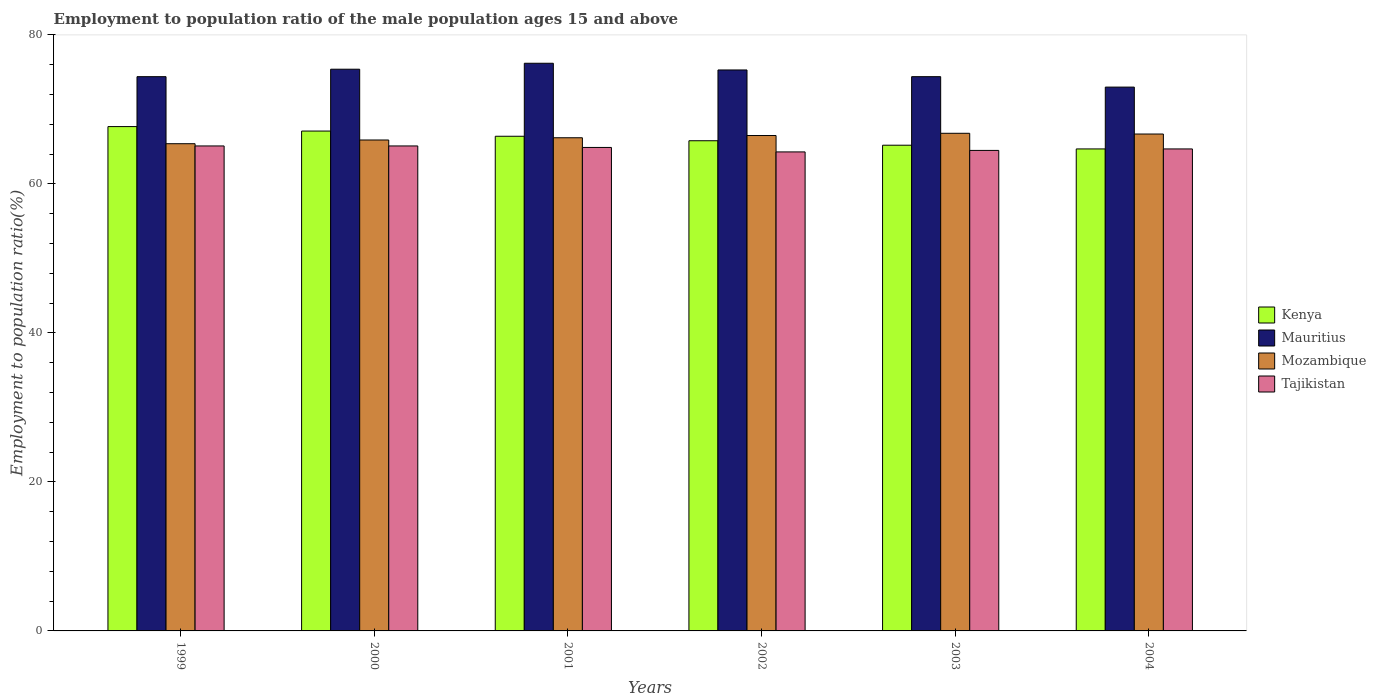How many different coloured bars are there?
Ensure brevity in your answer.  4. How many bars are there on the 5th tick from the left?
Keep it short and to the point. 4. What is the label of the 5th group of bars from the left?
Give a very brief answer. 2003. What is the employment to population ratio in Mozambique in 2002?
Give a very brief answer. 66.5. Across all years, what is the maximum employment to population ratio in Mauritius?
Your answer should be compact. 76.2. Across all years, what is the minimum employment to population ratio in Tajikistan?
Your answer should be very brief. 64.3. In which year was the employment to population ratio in Kenya maximum?
Provide a succinct answer. 1999. What is the total employment to population ratio in Kenya in the graph?
Your answer should be very brief. 396.9. What is the difference between the employment to population ratio in Mozambique in 2000 and that in 2001?
Provide a short and direct response. -0.3. What is the difference between the employment to population ratio in Mauritius in 2000 and the employment to population ratio in Kenya in 2004?
Your answer should be very brief. 10.7. What is the average employment to population ratio in Mozambique per year?
Make the answer very short. 66.25. In the year 1999, what is the difference between the employment to population ratio in Mozambique and employment to population ratio in Tajikistan?
Ensure brevity in your answer.  0.3. What is the ratio of the employment to population ratio in Mozambique in 2000 to that in 2003?
Offer a very short reply. 0.99. Is the employment to population ratio in Kenya in 1999 less than that in 2001?
Make the answer very short. No. Is the difference between the employment to population ratio in Mozambique in 2001 and 2004 greater than the difference between the employment to population ratio in Tajikistan in 2001 and 2004?
Provide a succinct answer. No. What is the difference between the highest and the second highest employment to population ratio in Kenya?
Offer a very short reply. 0.6. What is the difference between the highest and the lowest employment to population ratio in Mauritius?
Offer a terse response. 3.2. What does the 4th bar from the left in 2003 represents?
Your response must be concise. Tajikistan. What does the 4th bar from the right in 1999 represents?
Ensure brevity in your answer.  Kenya. Are all the bars in the graph horizontal?
Make the answer very short. No. How many years are there in the graph?
Your answer should be very brief. 6. What is the difference between two consecutive major ticks on the Y-axis?
Provide a succinct answer. 20. Are the values on the major ticks of Y-axis written in scientific E-notation?
Offer a very short reply. No. Does the graph contain grids?
Offer a very short reply. No. Where does the legend appear in the graph?
Your answer should be very brief. Center right. How many legend labels are there?
Provide a short and direct response. 4. How are the legend labels stacked?
Offer a terse response. Vertical. What is the title of the graph?
Give a very brief answer. Employment to population ratio of the male population ages 15 and above. What is the label or title of the X-axis?
Give a very brief answer. Years. What is the Employment to population ratio(%) in Kenya in 1999?
Give a very brief answer. 67.7. What is the Employment to population ratio(%) in Mauritius in 1999?
Provide a short and direct response. 74.4. What is the Employment to population ratio(%) of Mozambique in 1999?
Provide a short and direct response. 65.4. What is the Employment to population ratio(%) in Tajikistan in 1999?
Provide a short and direct response. 65.1. What is the Employment to population ratio(%) in Kenya in 2000?
Offer a very short reply. 67.1. What is the Employment to population ratio(%) in Mauritius in 2000?
Ensure brevity in your answer.  75.4. What is the Employment to population ratio(%) in Mozambique in 2000?
Provide a short and direct response. 65.9. What is the Employment to population ratio(%) of Tajikistan in 2000?
Provide a succinct answer. 65.1. What is the Employment to population ratio(%) of Kenya in 2001?
Keep it short and to the point. 66.4. What is the Employment to population ratio(%) in Mauritius in 2001?
Make the answer very short. 76.2. What is the Employment to population ratio(%) in Mozambique in 2001?
Provide a short and direct response. 66.2. What is the Employment to population ratio(%) in Tajikistan in 2001?
Make the answer very short. 64.9. What is the Employment to population ratio(%) in Kenya in 2002?
Make the answer very short. 65.8. What is the Employment to population ratio(%) of Mauritius in 2002?
Provide a short and direct response. 75.3. What is the Employment to population ratio(%) in Mozambique in 2002?
Offer a very short reply. 66.5. What is the Employment to population ratio(%) in Tajikistan in 2002?
Keep it short and to the point. 64.3. What is the Employment to population ratio(%) of Kenya in 2003?
Your answer should be compact. 65.2. What is the Employment to population ratio(%) in Mauritius in 2003?
Provide a succinct answer. 74.4. What is the Employment to population ratio(%) of Mozambique in 2003?
Provide a short and direct response. 66.8. What is the Employment to population ratio(%) of Tajikistan in 2003?
Ensure brevity in your answer.  64.5. What is the Employment to population ratio(%) of Kenya in 2004?
Your answer should be very brief. 64.7. What is the Employment to population ratio(%) in Mozambique in 2004?
Give a very brief answer. 66.7. What is the Employment to population ratio(%) of Tajikistan in 2004?
Ensure brevity in your answer.  64.7. Across all years, what is the maximum Employment to population ratio(%) of Kenya?
Provide a short and direct response. 67.7. Across all years, what is the maximum Employment to population ratio(%) of Mauritius?
Provide a succinct answer. 76.2. Across all years, what is the maximum Employment to population ratio(%) in Mozambique?
Give a very brief answer. 66.8. Across all years, what is the maximum Employment to population ratio(%) in Tajikistan?
Make the answer very short. 65.1. Across all years, what is the minimum Employment to population ratio(%) of Kenya?
Your response must be concise. 64.7. Across all years, what is the minimum Employment to population ratio(%) of Mauritius?
Provide a short and direct response. 73. Across all years, what is the minimum Employment to population ratio(%) of Mozambique?
Keep it short and to the point. 65.4. Across all years, what is the minimum Employment to population ratio(%) in Tajikistan?
Offer a terse response. 64.3. What is the total Employment to population ratio(%) of Kenya in the graph?
Provide a succinct answer. 396.9. What is the total Employment to population ratio(%) in Mauritius in the graph?
Give a very brief answer. 448.7. What is the total Employment to population ratio(%) of Mozambique in the graph?
Provide a short and direct response. 397.5. What is the total Employment to population ratio(%) in Tajikistan in the graph?
Offer a terse response. 388.6. What is the difference between the Employment to population ratio(%) of Mozambique in 1999 and that in 2000?
Make the answer very short. -0.5. What is the difference between the Employment to population ratio(%) of Tajikistan in 1999 and that in 2000?
Ensure brevity in your answer.  0. What is the difference between the Employment to population ratio(%) of Kenya in 1999 and that in 2002?
Offer a terse response. 1.9. What is the difference between the Employment to population ratio(%) in Mozambique in 1999 and that in 2002?
Make the answer very short. -1.1. What is the difference between the Employment to population ratio(%) of Tajikistan in 1999 and that in 2002?
Provide a succinct answer. 0.8. What is the difference between the Employment to population ratio(%) of Mauritius in 1999 and that in 2003?
Your answer should be compact. 0. What is the difference between the Employment to population ratio(%) in Mozambique in 1999 and that in 2003?
Make the answer very short. -1.4. What is the difference between the Employment to population ratio(%) in Kenya in 1999 and that in 2004?
Provide a succinct answer. 3. What is the difference between the Employment to population ratio(%) in Mauritius in 1999 and that in 2004?
Keep it short and to the point. 1.4. What is the difference between the Employment to population ratio(%) in Tajikistan in 1999 and that in 2004?
Your answer should be very brief. 0.4. What is the difference between the Employment to population ratio(%) in Kenya in 2000 and that in 2002?
Offer a terse response. 1.3. What is the difference between the Employment to population ratio(%) of Mauritius in 2000 and that in 2002?
Your answer should be very brief. 0.1. What is the difference between the Employment to population ratio(%) in Tajikistan in 2000 and that in 2002?
Give a very brief answer. 0.8. What is the difference between the Employment to population ratio(%) of Kenya in 2000 and that in 2003?
Your response must be concise. 1.9. What is the difference between the Employment to population ratio(%) in Mauritius in 2000 and that in 2003?
Your answer should be very brief. 1. What is the difference between the Employment to population ratio(%) in Tajikistan in 2000 and that in 2003?
Your response must be concise. 0.6. What is the difference between the Employment to population ratio(%) of Mauritius in 2000 and that in 2004?
Ensure brevity in your answer.  2.4. What is the difference between the Employment to population ratio(%) in Mozambique in 2000 and that in 2004?
Your response must be concise. -0.8. What is the difference between the Employment to population ratio(%) of Tajikistan in 2000 and that in 2004?
Your answer should be compact. 0.4. What is the difference between the Employment to population ratio(%) in Kenya in 2001 and that in 2002?
Your answer should be compact. 0.6. What is the difference between the Employment to population ratio(%) of Mozambique in 2001 and that in 2002?
Give a very brief answer. -0.3. What is the difference between the Employment to population ratio(%) of Tajikistan in 2001 and that in 2002?
Your answer should be compact. 0.6. What is the difference between the Employment to population ratio(%) in Mauritius in 2001 and that in 2003?
Your answer should be compact. 1.8. What is the difference between the Employment to population ratio(%) in Tajikistan in 2001 and that in 2003?
Make the answer very short. 0.4. What is the difference between the Employment to population ratio(%) in Kenya in 2001 and that in 2004?
Offer a terse response. 1.7. What is the difference between the Employment to population ratio(%) of Kenya in 2002 and that in 2003?
Offer a very short reply. 0.6. What is the difference between the Employment to population ratio(%) in Mauritius in 2002 and that in 2003?
Provide a succinct answer. 0.9. What is the difference between the Employment to population ratio(%) of Mozambique in 2002 and that in 2003?
Offer a very short reply. -0.3. What is the difference between the Employment to population ratio(%) in Tajikistan in 2002 and that in 2003?
Ensure brevity in your answer.  -0.2. What is the difference between the Employment to population ratio(%) of Mozambique in 2002 and that in 2004?
Provide a short and direct response. -0.2. What is the difference between the Employment to population ratio(%) of Tajikistan in 2002 and that in 2004?
Your answer should be very brief. -0.4. What is the difference between the Employment to population ratio(%) of Mauritius in 2003 and that in 2004?
Make the answer very short. 1.4. What is the difference between the Employment to population ratio(%) in Kenya in 1999 and the Employment to population ratio(%) in Mauritius in 2000?
Your response must be concise. -7.7. What is the difference between the Employment to population ratio(%) of Kenya in 1999 and the Employment to population ratio(%) of Mozambique in 2000?
Give a very brief answer. 1.8. What is the difference between the Employment to population ratio(%) in Mauritius in 1999 and the Employment to population ratio(%) in Tajikistan in 2000?
Offer a very short reply. 9.3. What is the difference between the Employment to population ratio(%) in Mozambique in 1999 and the Employment to population ratio(%) in Tajikistan in 2000?
Your response must be concise. 0.3. What is the difference between the Employment to population ratio(%) in Kenya in 1999 and the Employment to population ratio(%) in Mauritius in 2001?
Offer a terse response. -8.5. What is the difference between the Employment to population ratio(%) in Kenya in 1999 and the Employment to population ratio(%) in Mozambique in 2001?
Give a very brief answer. 1.5. What is the difference between the Employment to population ratio(%) in Kenya in 1999 and the Employment to population ratio(%) in Tajikistan in 2001?
Your answer should be very brief. 2.8. What is the difference between the Employment to population ratio(%) of Mauritius in 1999 and the Employment to population ratio(%) of Mozambique in 2001?
Provide a succinct answer. 8.2. What is the difference between the Employment to population ratio(%) of Mauritius in 1999 and the Employment to population ratio(%) of Tajikistan in 2001?
Your response must be concise. 9.5. What is the difference between the Employment to population ratio(%) in Mozambique in 1999 and the Employment to population ratio(%) in Tajikistan in 2001?
Provide a short and direct response. 0.5. What is the difference between the Employment to population ratio(%) in Mauritius in 1999 and the Employment to population ratio(%) in Tajikistan in 2002?
Your answer should be compact. 10.1. What is the difference between the Employment to population ratio(%) in Mauritius in 1999 and the Employment to population ratio(%) in Mozambique in 2003?
Provide a succinct answer. 7.6. What is the difference between the Employment to population ratio(%) in Mauritius in 1999 and the Employment to population ratio(%) in Tajikistan in 2003?
Offer a terse response. 9.9. What is the difference between the Employment to population ratio(%) of Kenya in 1999 and the Employment to population ratio(%) of Tajikistan in 2004?
Offer a very short reply. 3. What is the difference between the Employment to population ratio(%) of Mauritius in 1999 and the Employment to population ratio(%) of Tajikistan in 2004?
Provide a short and direct response. 9.7. What is the difference between the Employment to population ratio(%) of Mozambique in 1999 and the Employment to population ratio(%) of Tajikistan in 2004?
Your answer should be very brief. 0.7. What is the difference between the Employment to population ratio(%) of Kenya in 2000 and the Employment to population ratio(%) of Mauritius in 2001?
Your answer should be compact. -9.1. What is the difference between the Employment to population ratio(%) in Kenya in 2000 and the Employment to population ratio(%) in Mozambique in 2001?
Make the answer very short. 0.9. What is the difference between the Employment to population ratio(%) of Kenya in 2000 and the Employment to population ratio(%) of Tajikistan in 2001?
Make the answer very short. 2.2. What is the difference between the Employment to population ratio(%) of Mauritius in 2000 and the Employment to population ratio(%) of Mozambique in 2001?
Give a very brief answer. 9.2. What is the difference between the Employment to population ratio(%) in Mauritius in 2000 and the Employment to population ratio(%) in Tajikistan in 2001?
Your answer should be very brief. 10.5. What is the difference between the Employment to population ratio(%) in Mozambique in 2000 and the Employment to population ratio(%) in Tajikistan in 2001?
Give a very brief answer. 1. What is the difference between the Employment to population ratio(%) of Kenya in 2000 and the Employment to population ratio(%) of Mauritius in 2002?
Ensure brevity in your answer.  -8.2. What is the difference between the Employment to population ratio(%) of Kenya in 2000 and the Employment to population ratio(%) of Mozambique in 2002?
Make the answer very short. 0.6. What is the difference between the Employment to population ratio(%) in Kenya in 2000 and the Employment to population ratio(%) in Tajikistan in 2002?
Make the answer very short. 2.8. What is the difference between the Employment to population ratio(%) in Mauritius in 2000 and the Employment to population ratio(%) in Mozambique in 2002?
Give a very brief answer. 8.9. What is the difference between the Employment to population ratio(%) of Kenya in 2000 and the Employment to population ratio(%) of Tajikistan in 2003?
Ensure brevity in your answer.  2.6. What is the difference between the Employment to population ratio(%) in Mauritius in 2000 and the Employment to population ratio(%) in Tajikistan in 2003?
Provide a short and direct response. 10.9. What is the difference between the Employment to population ratio(%) of Kenya in 2000 and the Employment to population ratio(%) of Mauritius in 2004?
Keep it short and to the point. -5.9. What is the difference between the Employment to population ratio(%) of Kenya in 2000 and the Employment to population ratio(%) of Tajikistan in 2004?
Make the answer very short. 2.4. What is the difference between the Employment to population ratio(%) in Mauritius in 2000 and the Employment to population ratio(%) in Tajikistan in 2004?
Your response must be concise. 10.7. What is the difference between the Employment to population ratio(%) in Mozambique in 2000 and the Employment to population ratio(%) in Tajikistan in 2004?
Your answer should be compact. 1.2. What is the difference between the Employment to population ratio(%) of Kenya in 2001 and the Employment to population ratio(%) of Mauritius in 2002?
Your response must be concise. -8.9. What is the difference between the Employment to population ratio(%) of Kenya in 2001 and the Employment to population ratio(%) of Tajikistan in 2002?
Give a very brief answer. 2.1. What is the difference between the Employment to population ratio(%) of Mauritius in 2001 and the Employment to population ratio(%) of Mozambique in 2002?
Offer a very short reply. 9.7. What is the difference between the Employment to population ratio(%) in Mauritius in 2001 and the Employment to population ratio(%) in Tajikistan in 2003?
Provide a succinct answer. 11.7. What is the difference between the Employment to population ratio(%) of Mozambique in 2001 and the Employment to population ratio(%) of Tajikistan in 2003?
Provide a succinct answer. 1.7. What is the difference between the Employment to population ratio(%) of Kenya in 2001 and the Employment to population ratio(%) of Mozambique in 2004?
Keep it short and to the point. -0.3. What is the difference between the Employment to population ratio(%) of Kenya in 2001 and the Employment to population ratio(%) of Tajikistan in 2004?
Give a very brief answer. 1.7. What is the difference between the Employment to population ratio(%) of Mauritius in 2001 and the Employment to population ratio(%) of Mozambique in 2004?
Your answer should be compact. 9.5. What is the difference between the Employment to population ratio(%) of Mauritius in 2001 and the Employment to population ratio(%) of Tajikistan in 2004?
Offer a very short reply. 11.5. What is the difference between the Employment to population ratio(%) in Mozambique in 2001 and the Employment to population ratio(%) in Tajikistan in 2004?
Offer a terse response. 1.5. What is the difference between the Employment to population ratio(%) in Kenya in 2002 and the Employment to population ratio(%) in Tajikistan in 2003?
Provide a short and direct response. 1.3. What is the difference between the Employment to population ratio(%) in Kenya in 2002 and the Employment to population ratio(%) in Mauritius in 2004?
Your response must be concise. -7.2. What is the difference between the Employment to population ratio(%) in Kenya in 2002 and the Employment to population ratio(%) in Tajikistan in 2004?
Give a very brief answer. 1.1. What is the difference between the Employment to population ratio(%) of Mauritius in 2002 and the Employment to population ratio(%) of Mozambique in 2004?
Your answer should be very brief. 8.6. What is the difference between the Employment to population ratio(%) of Mauritius in 2002 and the Employment to population ratio(%) of Tajikistan in 2004?
Keep it short and to the point. 10.6. What is the difference between the Employment to population ratio(%) of Mozambique in 2002 and the Employment to population ratio(%) of Tajikistan in 2004?
Keep it short and to the point. 1.8. What is the difference between the Employment to population ratio(%) in Kenya in 2003 and the Employment to population ratio(%) in Mozambique in 2004?
Your response must be concise. -1.5. What is the average Employment to population ratio(%) in Kenya per year?
Your response must be concise. 66.15. What is the average Employment to population ratio(%) of Mauritius per year?
Your response must be concise. 74.78. What is the average Employment to population ratio(%) of Mozambique per year?
Your response must be concise. 66.25. What is the average Employment to population ratio(%) in Tajikistan per year?
Provide a succinct answer. 64.77. In the year 1999, what is the difference between the Employment to population ratio(%) in Kenya and Employment to population ratio(%) in Mozambique?
Provide a short and direct response. 2.3. In the year 1999, what is the difference between the Employment to population ratio(%) in Kenya and Employment to population ratio(%) in Tajikistan?
Give a very brief answer. 2.6. In the year 1999, what is the difference between the Employment to population ratio(%) in Mauritius and Employment to population ratio(%) in Mozambique?
Your answer should be compact. 9. In the year 1999, what is the difference between the Employment to population ratio(%) in Mauritius and Employment to population ratio(%) in Tajikistan?
Provide a succinct answer. 9.3. In the year 1999, what is the difference between the Employment to population ratio(%) of Mozambique and Employment to population ratio(%) of Tajikistan?
Your response must be concise. 0.3. In the year 2000, what is the difference between the Employment to population ratio(%) in Kenya and Employment to population ratio(%) in Mozambique?
Keep it short and to the point. 1.2. In the year 2000, what is the difference between the Employment to population ratio(%) of Mauritius and Employment to population ratio(%) of Mozambique?
Keep it short and to the point. 9.5. In the year 2001, what is the difference between the Employment to population ratio(%) in Mauritius and Employment to population ratio(%) in Mozambique?
Your answer should be very brief. 10. In the year 2001, what is the difference between the Employment to population ratio(%) of Mozambique and Employment to population ratio(%) of Tajikistan?
Provide a short and direct response. 1.3. In the year 2002, what is the difference between the Employment to population ratio(%) in Kenya and Employment to population ratio(%) in Mauritius?
Keep it short and to the point. -9.5. In the year 2002, what is the difference between the Employment to population ratio(%) in Mauritius and Employment to population ratio(%) in Mozambique?
Offer a very short reply. 8.8. In the year 2002, what is the difference between the Employment to population ratio(%) of Mauritius and Employment to population ratio(%) of Tajikistan?
Keep it short and to the point. 11. In the year 2003, what is the difference between the Employment to population ratio(%) of Kenya and Employment to population ratio(%) of Mauritius?
Your response must be concise. -9.2. In the year 2003, what is the difference between the Employment to population ratio(%) of Kenya and Employment to population ratio(%) of Mozambique?
Provide a succinct answer. -1.6. In the year 2003, what is the difference between the Employment to population ratio(%) of Mauritius and Employment to population ratio(%) of Tajikistan?
Your answer should be very brief. 9.9. In the year 2003, what is the difference between the Employment to population ratio(%) of Mozambique and Employment to population ratio(%) of Tajikistan?
Your response must be concise. 2.3. In the year 2004, what is the difference between the Employment to population ratio(%) in Kenya and Employment to population ratio(%) in Mauritius?
Offer a very short reply. -8.3. In the year 2004, what is the difference between the Employment to population ratio(%) of Kenya and Employment to population ratio(%) of Mozambique?
Give a very brief answer. -2. In the year 2004, what is the difference between the Employment to population ratio(%) in Mauritius and Employment to population ratio(%) in Mozambique?
Provide a short and direct response. 6.3. What is the ratio of the Employment to population ratio(%) of Kenya in 1999 to that in 2000?
Your answer should be very brief. 1.01. What is the ratio of the Employment to population ratio(%) in Mauritius in 1999 to that in 2000?
Ensure brevity in your answer.  0.99. What is the ratio of the Employment to population ratio(%) in Tajikistan in 1999 to that in 2000?
Your answer should be compact. 1. What is the ratio of the Employment to population ratio(%) in Kenya in 1999 to that in 2001?
Your answer should be very brief. 1.02. What is the ratio of the Employment to population ratio(%) in Mauritius in 1999 to that in 2001?
Your answer should be compact. 0.98. What is the ratio of the Employment to population ratio(%) in Mozambique in 1999 to that in 2001?
Offer a very short reply. 0.99. What is the ratio of the Employment to population ratio(%) in Tajikistan in 1999 to that in 2001?
Give a very brief answer. 1. What is the ratio of the Employment to population ratio(%) of Kenya in 1999 to that in 2002?
Your answer should be compact. 1.03. What is the ratio of the Employment to population ratio(%) of Mauritius in 1999 to that in 2002?
Your response must be concise. 0.99. What is the ratio of the Employment to population ratio(%) of Mozambique in 1999 to that in 2002?
Your response must be concise. 0.98. What is the ratio of the Employment to population ratio(%) in Tajikistan in 1999 to that in 2002?
Offer a terse response. 1.01. What is the ratio of the Employment to population ratio(%) of Kenya in 1999 to that in 2003?
Your answer should be compact. 1.04. What is the ratio of the Employment to population ratio(%) in Mozambique in 1999 to that in 2003?
Give a very brief answer. 0.98. What is the ratio of the Employment to population ratio(%) of Tajikistan in 1999 to that in 2003?
Your answer should be compact. 1.01. What is the ratio of the Employment to population ratio(%) in Kenya in 1999 to that in 2004?
Your response must be concise. 1.05. What is the ratio of the Employment to population ratio(%) in Mauritius in 1999 to that in 2004?
Your answer should be compact. 1.02. What is the ratio of the Employment to population ratio(%) of Mozambique in 1999 to that in 2004?
Your answer should be compact. 0.98. What is the ratio of the Employment to population ratio(%) of Kenya in 2000 to that in 2001?
Ensure brevity in your answer.  1.01. What is the ratio of the Employment to population ratio(%) of Tajikistan in 2000 to that in 2001?
Provide a succinct answer. 1. What is the ratio of the Employment to population ratio(%) in Kenya in 2000 to that in 2002?
Offer a very short reply. 1.02. What is the ratio of the Employment to population ratio(%) of Mauritius in 2000 to that in 2002?
Keep it short and to the point. 1. What is the ratio of the Employment to population ratio(%) in Mozambique in 2000 to that in 2002?
Give a very brief answer. 0.99. What is the ratio of the Employment to population ratio(%) in Tajikistan in 2000 to that in 2002?
Your answer should be very brief. 1.01. What is the ratio of the Employment to population ratio(%) of Kenya in 2000 to that in 2003?
Offer a very short reply. 1.03. What is the ratio of the Employment to population ratio(%) of Mauritius in 2000 to that in 2003?
Your response must be concise. 1.01. What is the ratio of the Employment to population ratio(%) of Mozambique in 2000 to that in 2003?
Make the answer very short. 0.99. What is the ratio of the Employment to population ratio(%) of Tajikistan in 2000 to that in 2003?
Provide a short and direct response. 1.01. What is the ratio of the Employment to population ratio(%) of Kenya in 2000 to that in 2004?
Provide a succinct answer. 1.04. What is the ratio of the Employment to population ratio(%) in Mauritius in 2000 to that in 2004?
Ensure brevity in your answer.  1.03. What is the ratio of the Employment to population ratio(%) in Mozambique in 2000 to that in 2004?
Offer a terse response. 0.99. What is the ratio of the Employment to population ratio(%) of Kenya in 2001 to that in 2002?
Provide a short and direct response. 1.01. What is the ratio of the Employment to population ratio(%) in Mauritius in 2001 to that in 2002?
Your response must be concise. 1.01. What is the ratio of the Employment to population ratio(%) of Tajikistan in 2001 to that in 2002?
Provide a short and direct response. 1.01. What is the ratio of the Employment to population ratio(%) in Kenya in 2001 to that in 2003?
Provide a short and direct response. 1.02. What is the ratio of the Employment to population ratio(%) of Mauritius in 2001 to that in 2003?
Offer a very short reply. 1.02. What is the ratio of the Employment to population ratio(%) in Kenya in 2001 to that in 2004?
Ensure brevity in your answer.  1.03. What is the ratio of the Employment to population ratio(%) of Mauritius in 2001 to that in 2004?
Provide a short and direct response. 1.04. What is the ratio of the Employment to population ratio(%) of Tajikistan in 2001 to that in 2004?
Ensure brevity in your answer.  1. What is the ratio of the Employment to population ratio(%) of Kenya in 2002 to that in 2003?
Provide a succinct answer. 1.01. What is the ratio of the Employment to population ratio(%) in Mauritius in 2002 to that in 2003?
Make the answer very short. 1.01. What is the ratio of the Employment to population ratio(%) of Mozambique in 2002 to that in 2003?
Provide a short and direct response. 1. What is the ratio of the Employment to population ratio(%) in Kenya in 2002 to that in 2004?
Offer a terse response. 1.02. What is the ratio of the Employment to population ratio(%) of Mauritius in 2002 to that in 2004?
Give a very brief answer. 1.03. What is the ratio of the Employment to population ratio(%) of Mozambique in 2002 to that in 2004?
Offer a very short reply. 1. What is the ratio of the Employment to population ratio(%) of Tajikistan in 2002 to that in 2004?
Give a very brief answer. 0.99. What is the ratio of the Employment to population ratio(%) in Kenya in 2003 to that in 2004?
Your answer should be very brief. 1.01. What is the ratio of the Employment to population ratio(%) in Mauritius in 2003 to that in 2004?
Your response must be concise. 1.02. What is the ratio of the Employment to population ratio(%) in Tajikistan in 2003 to that in 2004?
Provide a short and direct response. 1. What is the difference between the highest and the second highest Employment to population ratio(%) in Kenya?
Your response must be concise. 0.6. What is the difference between the highest and the second highest Employment to population ratio(%) of Mauritius?
Offer a terse response. 0.8. What is the difference between the highest and the second highest Employment to population ratio(%) in Mozambique?
Offer a terse response. 0.1. What is the difference between the highest and the second highest Employment to population ratio(%) in Tajikistan?
Make the answer very short. 0. What is the difference between the highest and the lowest Employment to population ratio(%) of Kenya?
Your answer should be compact. 3. What is the difference between the highest and the lowest Employment to population ratio(%) of Mozambique?
Your response must be concise. 1.4. What is the difference between the highest and the lowest Employment to population ratio(%) in Tajikistan?
Ensure brevity in your answer.  0.8. 